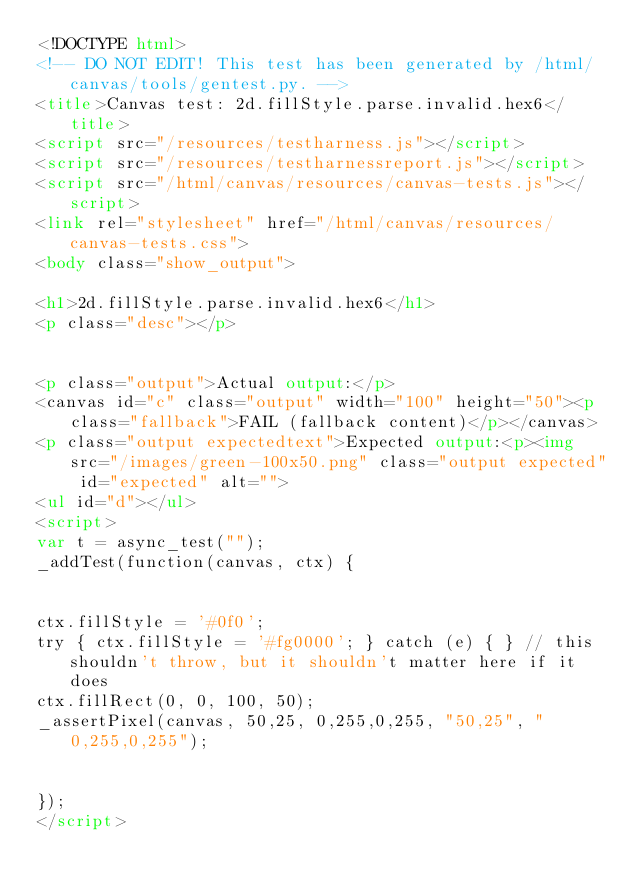<code> <loc_0><loc_0><loc_500><loc_500><_HTML_><!DOCTYPE html>
<!-- DO NOT EDIT! This test has been generated by /html/canvas/tools/gentest.py. -->
<title>Canvas test: 2d.fillStyle.parse.invalid.hex6</title>
<script src="/resources/testharness.js"></script>
<script src="/resources/testharnessreport.js"></script>
<script src="/html/canvas/resources/canvas-tests.js"></script>
<link rel="stylesheet" href="/html/canvas/resources/canvas-tests.css">
<body class="show_output">

<h1>2d.fillStyle.parse.invalid.hex6</h1>
<p class="desc"></p>


<p class="output">Actual output:</p>
<canvas id="c" class="output" width="100" height="50"><p class="fallback">FAIL (fallback content)</p></canvas>
<p class="output expectedtext">Expected output:<p><img src="/images/green-100x50.png" class="output expected" id="expected" alt="">
<ul id="d"></ul>
<script>
var t = async_test("");
_addTest(function(canvas, ctx) {


ctx.fillStyle = '#0f0';
try { ctx.fillStyle = '#fg0000'; } catch (e) { } // this shouldn't throw, but it shouldn't matter here if it does
ctx.fillRect(0, 0, 100, 50);
_assertPixel(canvas, 50,25, 0,255,0,255, "50,25", "0,255,0,255");


});
</script>

</code> 